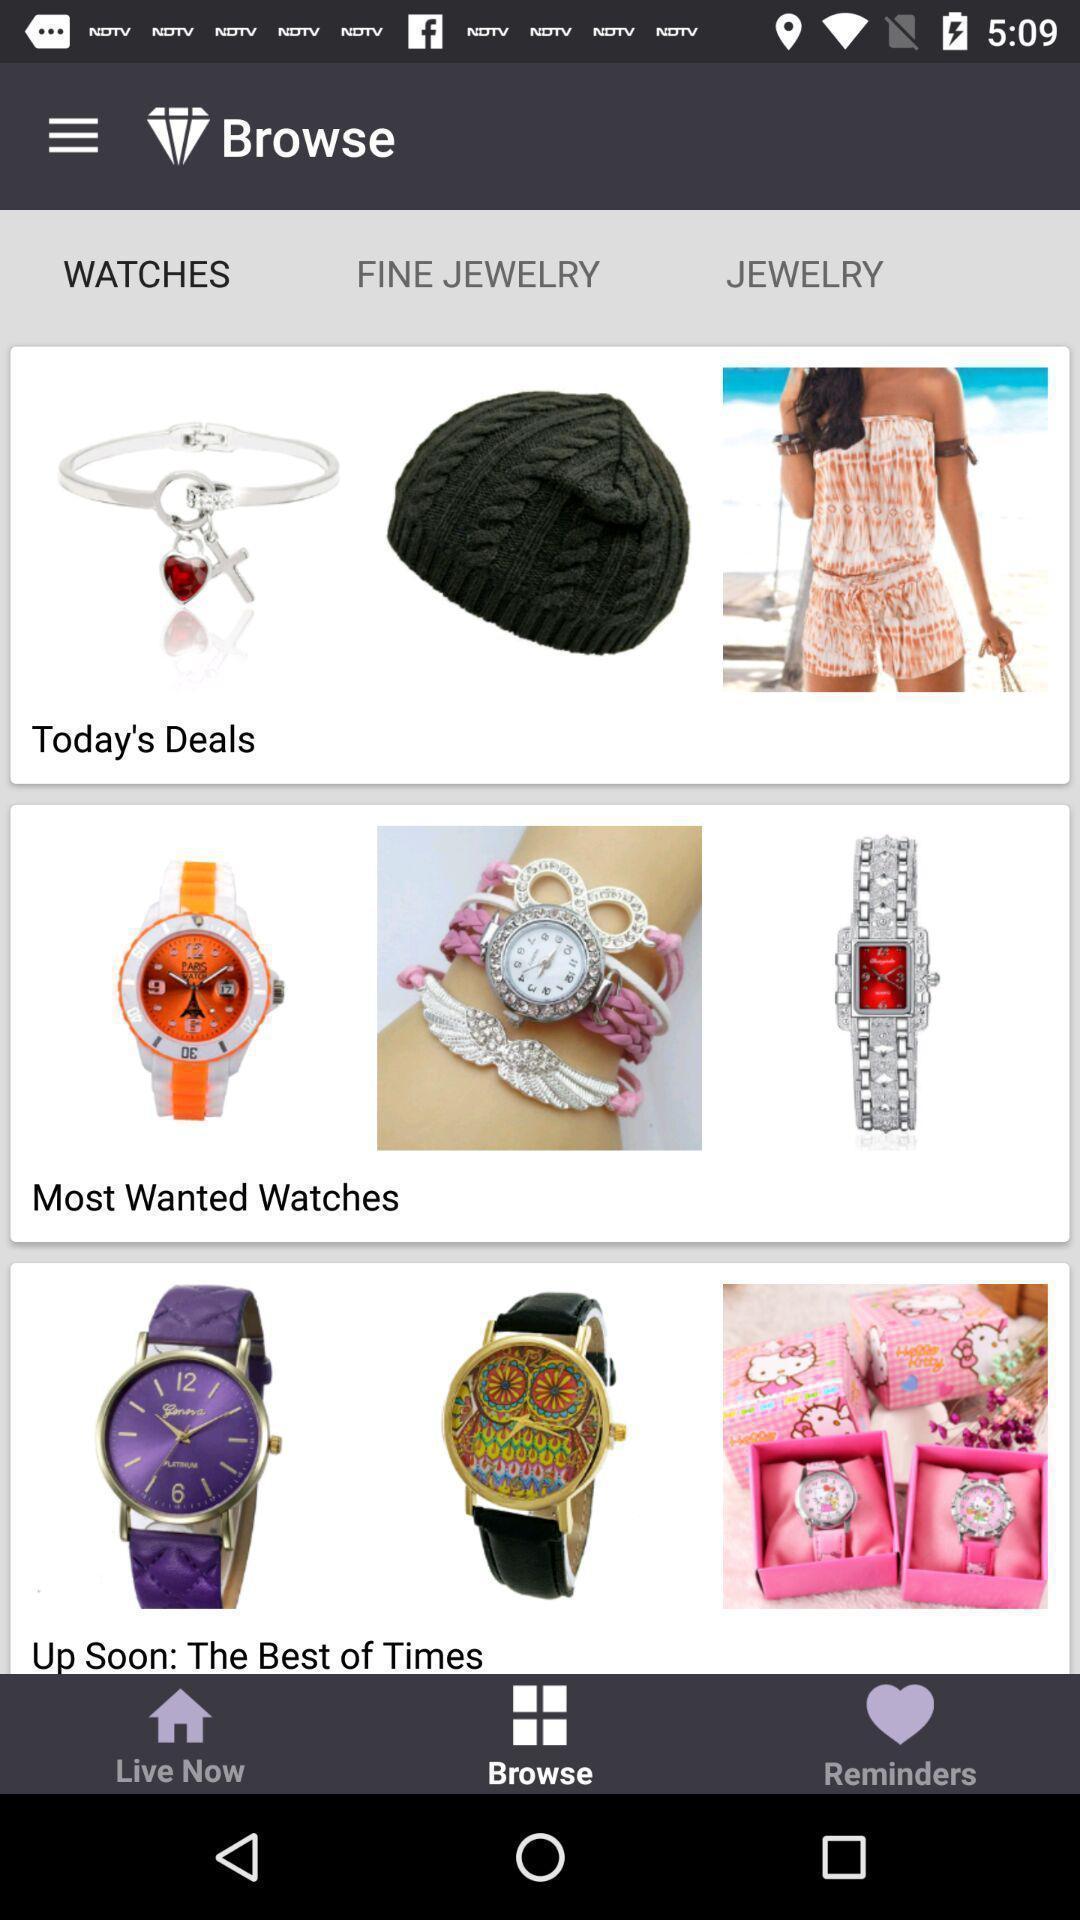Explain what's happening in this screen capture. Screen shows multiple products in a shopping application. 